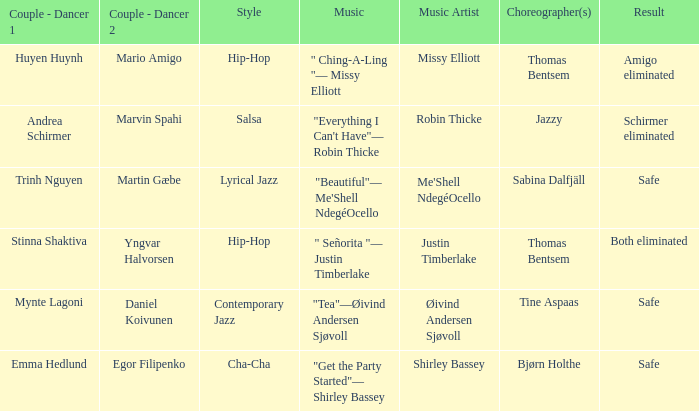What couple had a safe result and a lyrical jazz style? Trinh Nguyen Martin Gæbe. 